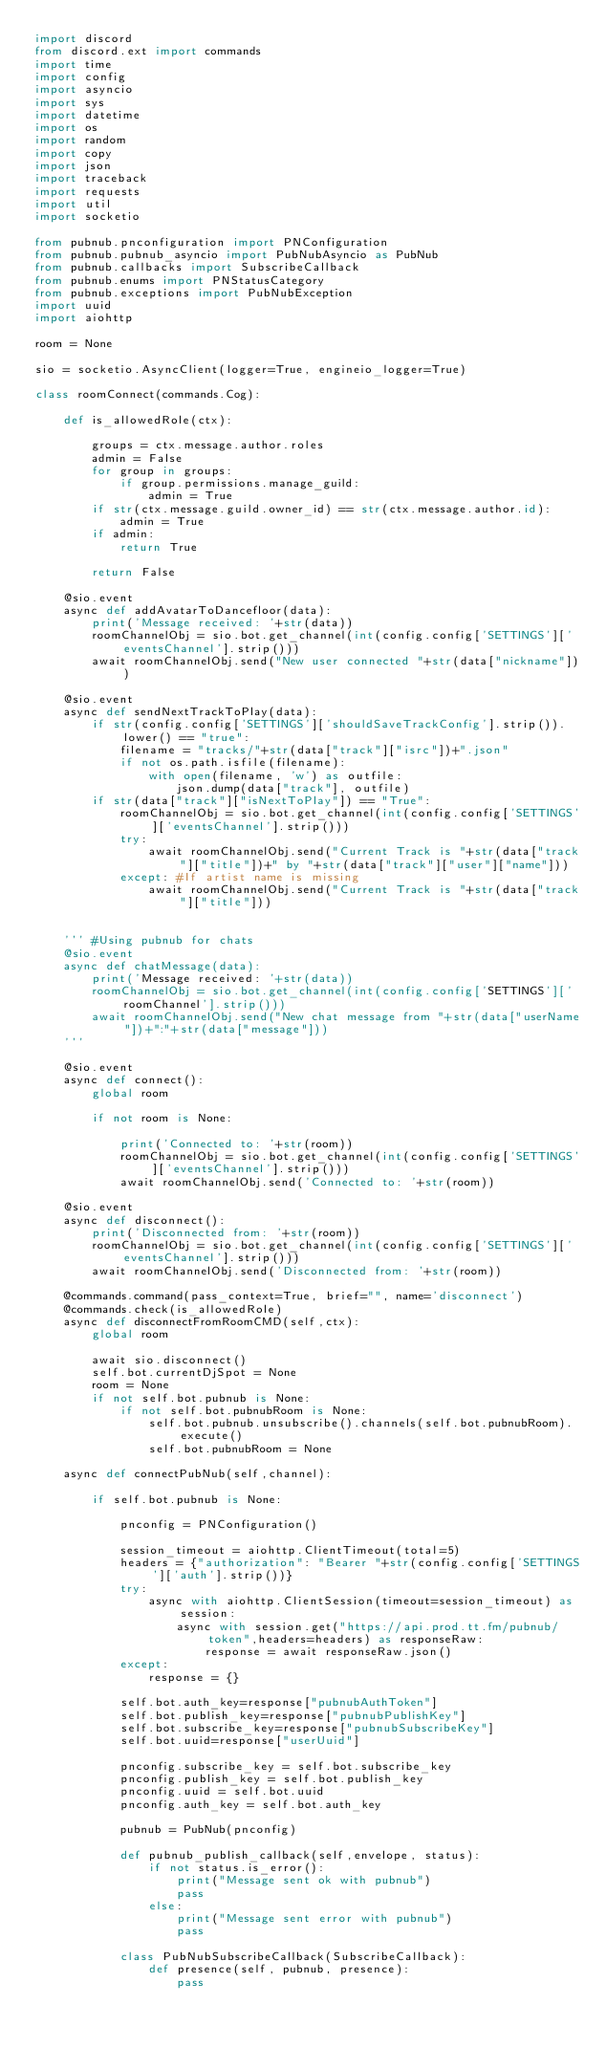<code> <loc_0><loc_0><loc_500><loc_500><_Python_>import discord
from discord.ext import commands
import time
import config
import asyncio
import sys
import datetime
import os
import random
import copy
import json
import traceback
import requests
import util
import socketio

from pubnub.pnconfiguration import PNConfiguration
from pubnub.pubnub_asyncio import PubNubAsyncio as PubNub
from pubnub.callbacks import SubscribeCallback
from pubnub.enums import PNStatusCategory
from pubnub.exceptions import PubNubException
import uuid
import aiohttp

room = None

sio = socketio.AsyncClient(logger=True, engineio_logger=True)

class roomConnect(commands.Cog):
	
	def is_allowedRole(ctx):
				
		groups = ctx.message.author.roles
		admin = False
		for group in groups:
			if group.permissions.manage_guild:
				admin = True
		if str(ctx.message.guild.owner_id) == str(ctx.message.author.id):
			admin = True
		if admin:
			return True
				
		return False
	
	@sio.event
	async def addAvatarToDancefloor(data):
		print('Message received: '+str(data))
		roomChannelObj = sio.bot.get_channel(int(config.config['SETTINGS']['eventsChannel'].strip()))
		await roomChannelObj.send("New user connected "+str(data["nickname"]))
	
	@sio.event
	async def sendNextTrackToPlay(data):
		if str(config.config['SETTINGS']['shouldSaveTrackConfig'].strip()).lower() == "true":
			filename = "tracks/"+str(data["track"]["isrc"])+".json"
			if not os.path.isfile(filename):
				with open(filename, 'w') as outfile:
					json.dump(data["track"], outfile)
		if str(data["track"]["isNextToPlay"]) == "True":
			roomChannelObj = sio.bot.get_channel(int(config.config['SETTINGS']['eventsChannel'].strip()))
			try:
				await roomChannelObj.send("Current Track is "+str(data["track"]["title"])+" by "+str(data["track"]["user"]["name"]))
			except: #If artist name is missing
				await roomChannelObj.send("Current Track is "+str(data["track"]["title"]))
		
			
	''' #Using pubnub for chats
	@sio.event
	async def chatMessage(data):
		print('Message received: '+str(data))
		roomChannelObj = sio.bot.get_channel(int(config.config['SETTINGS']['roomChannel'].strip()))
		await roomChannelObj.send("New chat message from "+str(data["userName"])+":"+str(data["message"]))
	'''
	
	@sio.event
	async def connect():
		global room
		
		if not room is None:
		
			print('Connected to: '+str(room))
			roomChannelObj = sio.bot.get_channel(int(config.config['SETTINGS']['eventsChannel'].strip()))
			await roomChannelObj.send('Connected to: '+str(room))
	
	@sio.event
	async def disconnect():
		print('Disconnected from: '+str(room))
		roomChannelObj = sio.bot.get_channel(int(config.config['SETTINGS']['eventsChannel'].strip()))
		await roomChannelObj.send('Disconnected from: '+str(room))
	
	@commands.command(pass_context=True, brief="", name='disconnect')
	@commands.check(is_allowedRole)
	async def disconnectFromRoomCMD(self,ctx):
		global room
		
		await sio.disconnect()
		self.bot.currentDjSpot = None
		room = None
		if not self.bot.pubnub is None:
			if not self.bot.pubnubRoom is None:
				self.bot.pubnub.unsubscribe().channels(self.bot.pubnubRoom).execute()
				self.bot.pubnubRoom = None
		
	async def connectPubNub(self,channel):
		
		if self.bot.pubnub is None:
		
			pnconfig = PNConfiguration()
			
			session_timeout = aiohttp.ClientTimeout(total=5)
			headers = {"authorization": "Bearer "+str(config.config['SETTINGS']['auth'].strip())}
			try:
				async with aiohttp.ClientSession(timeout=session_timeout) as session:
					async with session.get("https://api.prod.tt.fm/pubnub/token",headers=headers) as responseRaw:
						response = await responseRaw.json()
			except:
				response = {}
			
			self.bot.auth_key=response["pubnubAuthToken"]
			self.bot.publish_key=response["pubnubPublishKey"]
			self.bot.subscribe_key=response["pubnubSubscribeKey"]
			self.bot.uuid=response["userUuid"]
			
			pnconfig.subscribe_key = self.bot.subscribe_key
			pnconfig.publish_key = self.bot.publish_key
			pnconfig.uuid = self.bot.uuid
			pnconfig.auth_key = self.bot.auth_key
			
			pubnub = PubNub(pnconfig)
			
			def pubnub_publish_callback(self,envelope, status):
				if not status.is_error():
					print("Message sent ok with pubnub")
					pass
				else:
					print("Message sent error with pubnub")
					pass
			
			class PubNubSubscribeCallback(SubscribeCallback):
				def presence(self, pubnub, presence):
					pass
</code> 